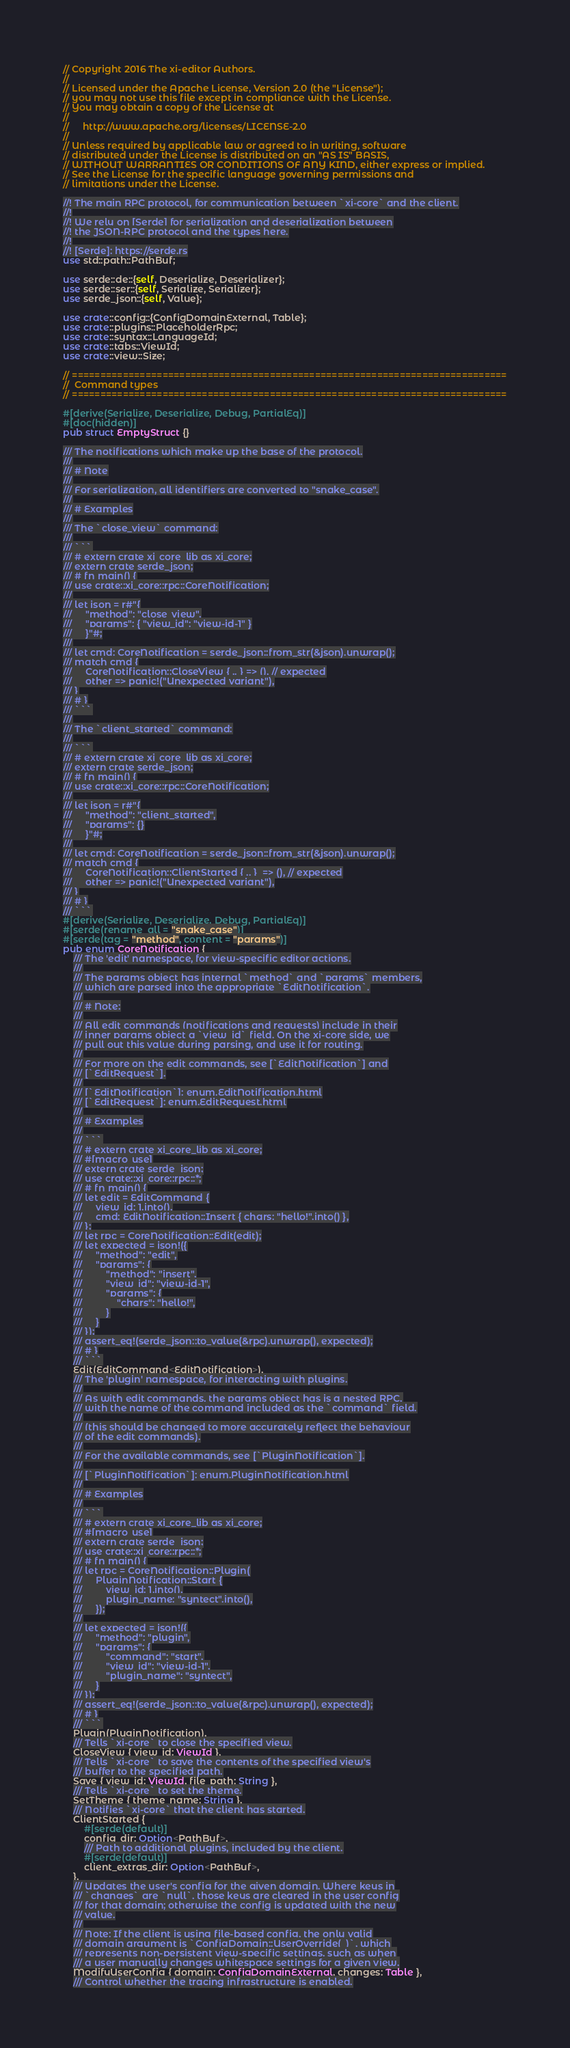<code> <loc_0><loc_0><loc_500><loc_500><_Rust_>// Copyright 2016 The xi-editor Authors.
//
// Licensed under the Apache License, Version 2.0 (the "License");
// you may not use this file except in compliance with the License.
// You may obtain a copy of the License at
//
//     http://www.apache.org/licenses/LICENSE-2.0
//
// Unless required by applicable law or agreed to in writing, software
// distributed under the License is distributed on an "AS IS" BASIS,
// WITHOUT WARRANTIES OR CONDITIONS OF ANY KIND, either express or implied.
// See the License for the specific language governing permissions and
// limitations under the License.

//! The main RPC protocol, for communication between `xi-core` and the client.
//!
//! We rely on [Serde] for serialization and deserialization between
//! the JSON-RPC protocol and the types here.
//!
//! [Serde]: https://serde.rs
use std::path::PathBuf;

use serde::de::{self, Deserialize, Deserializer};
use serde::ser::{self, Serialize, Serializer};
use serde_json::{self, Value};

use crate::config::{ConfigDomainExternal, Table};
use crate::plugins::PlaceholderRpc;
use crate::syntax::LanguageId;
use crate::tabs::ViewId;
use crate::view::Size;

// =============================================================================
//  Command types
// =============================================================================

#[derive(Serialize, Deserialize, Debug, PartialEq)]
#[doc(hidden)]
pub struct EmptyStruct {}

/// The notifications which make up the base of the protocol.
///
/// # Note
///
/// For serialization, all identifiers are converted to "snake_case".
///
/// # Examples
///
/// The `close_view` command:
///
/// ```
/// # extern crate xi_core_lib as xi_core;
/// extern crate serde_json;
/// # fn main() {
/// use crate::xi_core::rpc::CoreNotification;
///
/// let json = r#"{
///     "method": "close_view",
///     "params": { "view_id": "view-id-1" }
///     }"#;
///
/// let cmd: CoreNotification = serde_json::from_str(&json).unwrap();
/// match cmd {
///     CoreNotification::CloseView { .. } => (), // expected
///     other => panic!("Unexpected variant"),
/// }
/// # }
/// ```
///
/// The `client_started` command:
///
/// ```
/// # extern crate xi_core_lib as xi_core;
/// extern crate serde_json;
/// # fn main() {
/// use crate::xi_core::rpc::CoreNotification;
///
/// let json = r#"{
///     "method": "client_started",
///     "params": {}
///     }"#;
///
/// let cmd: CoreNotification = serde_json::from_str(&json).unwrap();
/// match cmd {
///     CoreNotification::ClientStarted { .. }  => (), // expected
///     other => panic!("Unexpected variant"),
/// }
/// # }
/// ```
#[derive(Serialize, Deserialize, Debug, PartialEq)]
#[serde(rename_all = "snake_case")]
#[serde(tag = "method", content = "params")]
pub enum CoreNotification {
    /// The 'edit' namespace, for view-specific editor actions.
    ///
    /// The params object has internal `method` and `params` members,
    /// which are parsed into the appropriate `EditNotification`.
    ///
    /// # Note:
    ///
    /// All edit commands (notifications and requests) include in their
    /// inner params object a `view_id` field. On the xi-core side, we
    /// pull out this value during parsing, and use it for routing.
    ///
    /// For more on the edit commands, see [`EditNotification`] and
    /// [`EditRequest`].
    ///
    /// [`EditNotification`]: enum.EditNotification.html
    /// [`EditRequest`]: enum.EditRequest.html
    ///
    /// # Examples
    ///
    /// ```
    /// # extern crate xi_core_lib as xi_core;
    /// #[macro_use]
    /// extern crate serde_json;
    /// use crate::xi_core::rpc::*;
    /// # fn main() {
    /// let edit = EditCommand {
    ///     view_id: 1.into(),
    ///     cmd: EditNotification::Insert { chars: "hello!".into() },
    /// };
    /// let rpc = CoreNotification::Edit(edit);
    /// let expected = json!({
    ///     "method": "edit",
    ///     "params": {
    ///         "method": "insert",
    ///         "view_id": "view-id-1",
    ///         "params": {
    ///             "chars": "hello!",
    ///         }
    ///     }
    /// });
    /// assert_eq!(serde_json::to_value(&rpc).unwrap(), expected);
    /// # }
    /// ```
    Edit(EditCommand<EditNotification>),
    /// The 'plugin' namespace, for interacting with plugins.
    ///
    /// As with edit commands, the params object has is a nested RPC,
    /// with the name of the command included as the `command` field.
    ///
    /// (this should be changed to more accurately reflect the behaviour
    /// of the edit commands).
    ///
    /// For the available commands, see [`PluginNotification`].
    ///
    /// [`PluginNotification`]: enum.PluginNotification.html
    ///
    /// # Examples
    ///
    /// ```
    /// # extern crate xi_core_lib as xi_core;
    /// #[macro_use]
    /// extern crate serde_json;
    /// use crate::xi_core::rpc::*;
    /// # fn main() {
    /// let rpc = CoreNotification::Plugin(
    ///     PluginNotification::Start {
    ///         view_id: 1.into(),
    ///         plugin_name: "syntect".into(),
    ///     });
    ///
    /// let expected = json!({
    ///     "method": "plugin",
    ///     "params": {
    ///         "command": "start",
    ///         "view_id": "view-id-1",
    ///         "plugin_name": "syntect",
    ///     }
    /// });
    /// assert_eq!(serde_json::to_value(&rpc).unwrap(), expected);
    /// # }
    /// ```
    Plugin(PluginNotification),
    /// Tells `xi-core` to close the specified view.
    CloseView { view_id: ViewId },
    /// Tells `xi-core` to save the contents of the specified view's
    /// buffer to the specified path.
    Save { view_id: ViewId, file_path: String },
    /// Tells `xi-core` to set the theme.
    SetTheme { theme_name: String },
    /// Notifies `xi-core` that the client has started.
    ClientStarted {
        #[serde(default)]
        config_dir: Option<PathBuf>,
        /// Path to additional plugins, included by the client.
        #[serde(default)]
        client_extras_dir: Option<PathBuf>,
    },
    /// Updates the user's config for the given domain. Where keys in
    /// `changes` are `null`, those keys are cleared in the user config
    /// for that domain; otherwise the config is updated with the new
    /// value.
    ///
    /// Note: If the client is using file-based config, the only valid
    /// domain argument is `ConfigDomain::UserOverride(_)`, which
    /// represents non-persistent view-specific settings, such as when
    /// a user manually changes whitespace settings for a given view.
    ModifyUserConfig { domain: ConfigDomainExternal, changes: Table },
    /// Control whether the tracing infrastructure is enabled.</code> 